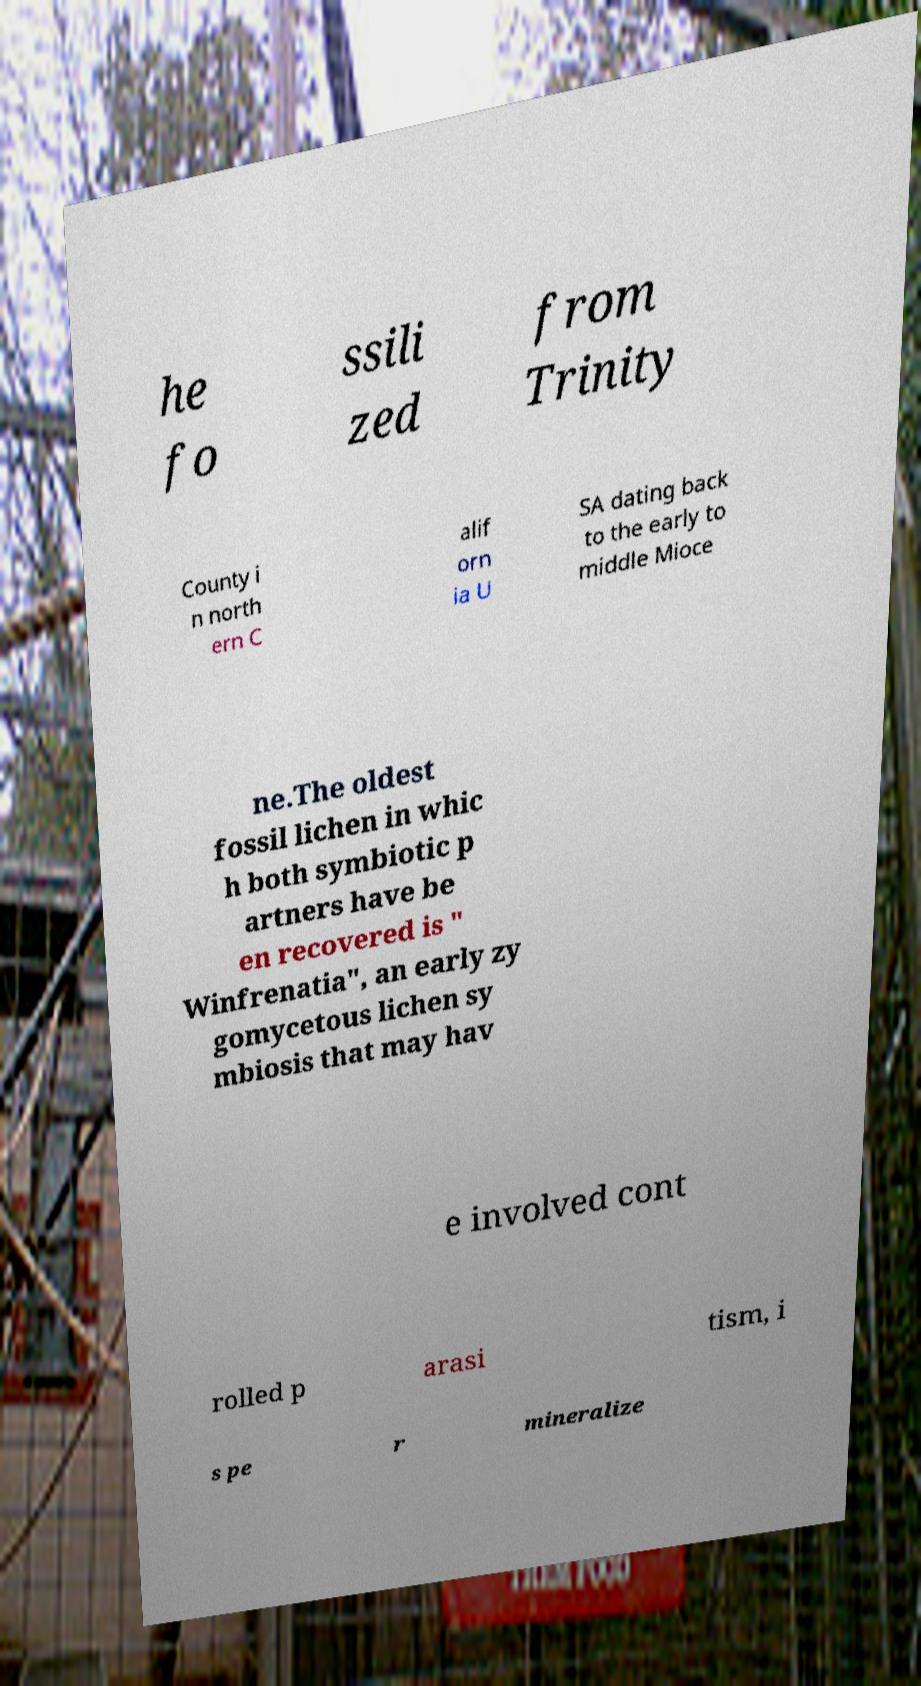Could you extract and type out the text from this image? he fo ssili zed from Trinity County i n north ern C alif orn ia U SA dating back to the early to middle Mioce ne.The oldest fossil lichen in whic h both symbiotic p artners have be en recovered is " Winfrenatia", an early zy gomycetous lichen sy mbiosis that may hav e involved cont rolled p arasi tism, i s pe r mineralize 